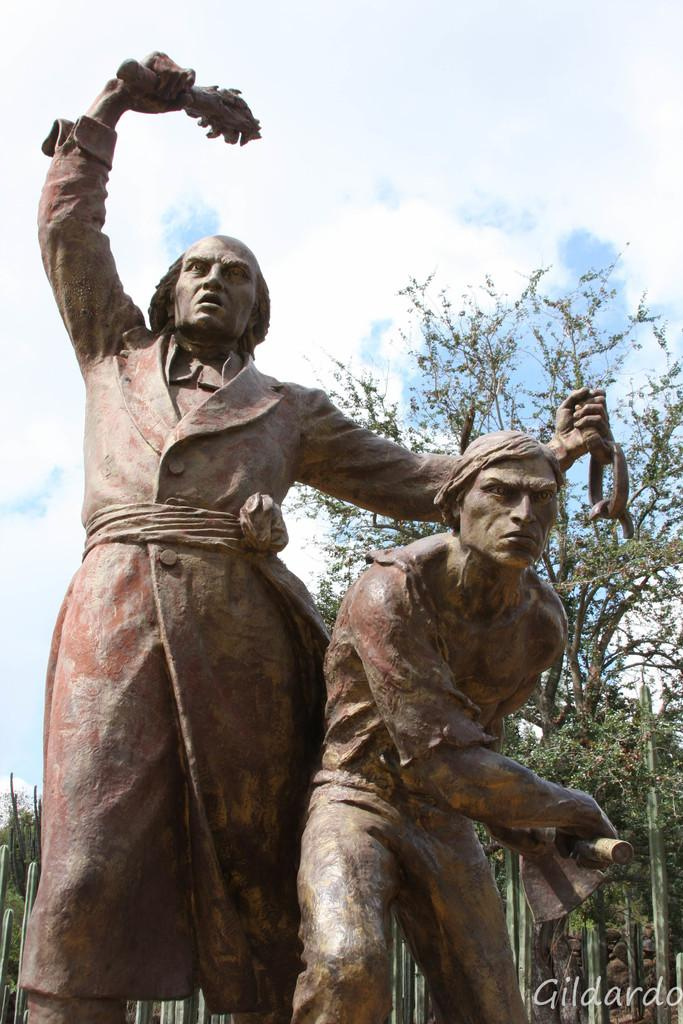What can be seen in the foreground of the image? There are two sculptures in the foreground of the image. What is located at the bottom of the image? There is text at the bottom of the image. What type of natural environment is visible behind the sculptures? Trees are visible behind the sculptures. What is visible at the top of the image? The sky is visible at the top of the image. Can you describe the crowd in the image? There is no crowd present in the image; it features two sculptures, text, trees, and the sky. 